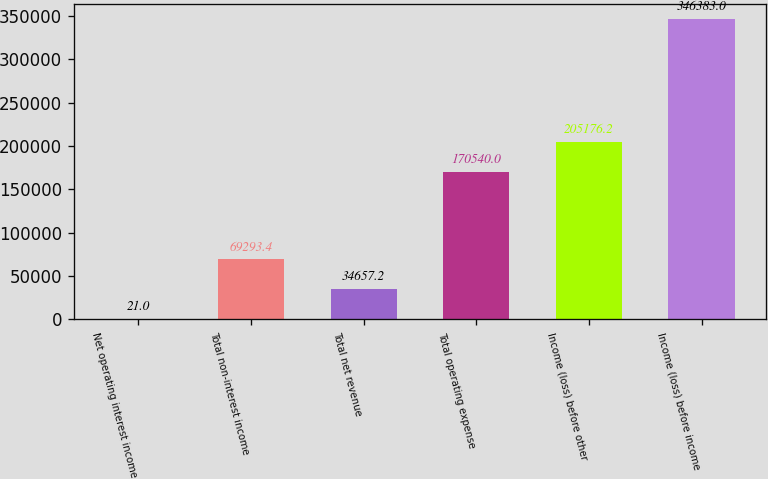Convert chart. <chart><loc_0><loc_0><loc_500><loc_500><bar_chart><fcel>Net operating interest income<fcel>Total non-interest income<fcel>Total net revenue<fcel>Total operating expense<fcel>Income (loss) before other<fcel>Income (loss) before income<nl><fcel>21<fcel>69293.4<fcel>34657.2<fcel>170540<fcel>205176<fcel>346383<nl></chart> 